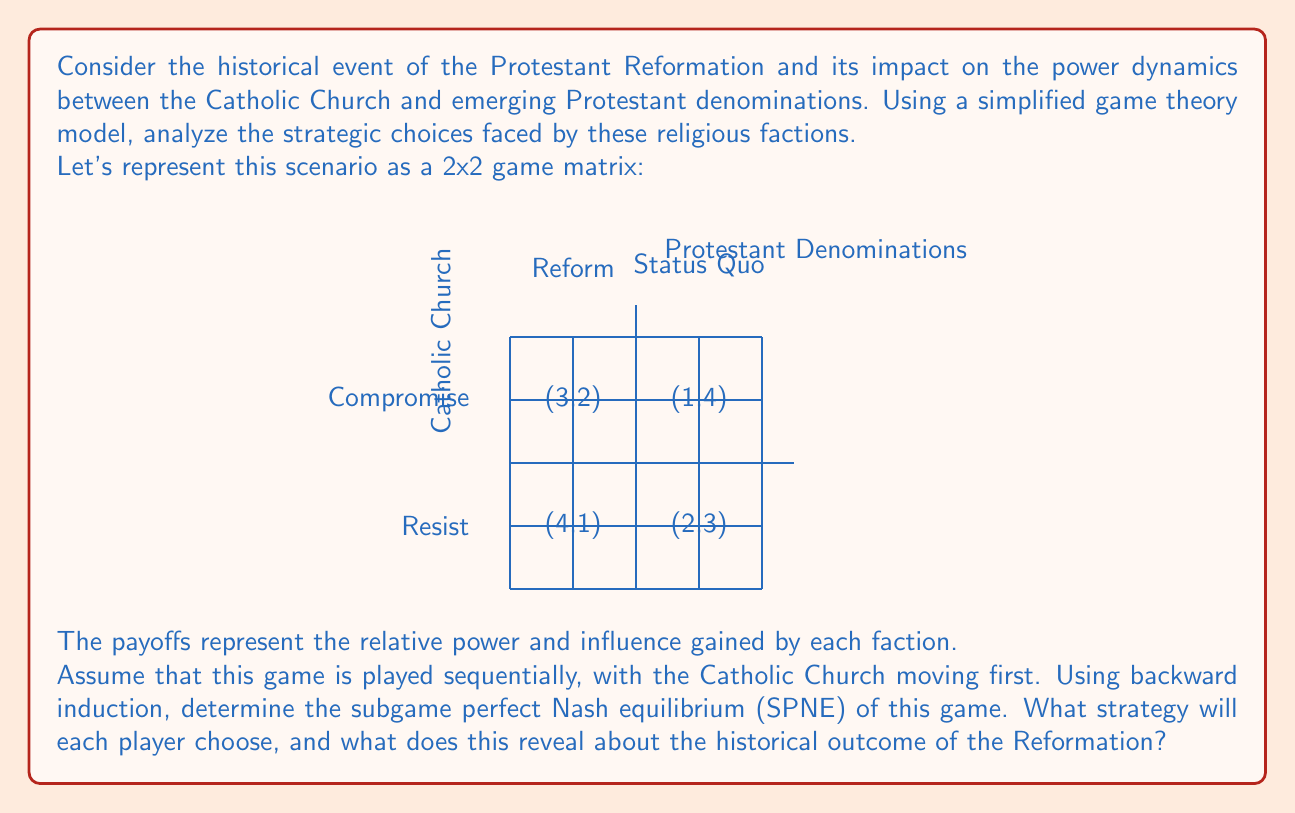Solve this math problem. To solve this problem using backward induction, we'll follow these steps:

1) First, we need to analyze the Protestant Denominations' best responses to each of the Catholic Church's possible moves:

   If Catholic Church chooses "Compromise":
   - Protestant chooses "Reform" (2 > 1)

   If Catholic Church chooses "Resist":
   - Protestant chooses "Status Quo" (3 > 1)

2) Now, knowing how the Protestant Denominations will respond, we can determine the Catholic Church's best move:

   If Catholic Church chooses "Compromise":
   - Outcome will be (Compromise, Reform) with payoff 3

   If Catholic Church chooses "Resist":
   - Outcome will be (Resist, Status Quo) with payoff 2

3) Therefore, the Catholic Church's best move is to choose "Compromise".

4) The subgame perfect Nash equilibrium (SPNE) is:
   Catholic Church: Compromise
   Protestant Denominations: Reform

5) The outcome is (Compromise, Reform) with payoffs (3, 2).

This result suggests that, in the long run, it was in the best interest of the Catholic Church to compromise and implement some reforms, while the Protestant Denominations gained by pushing for reforms. Historically, this aligns with the outcome of the Counter-Reformation, where the Catholic Church did indeed implement various reforms in response to Protestant criticisms.

The model demonstrates how game theory can provide insights into complex historical events by simplifying strategic interactions and revealing optimal choices for involved parties.
Answer: SPNE: (Compromise, Reform); Outcome: (3, 2) 